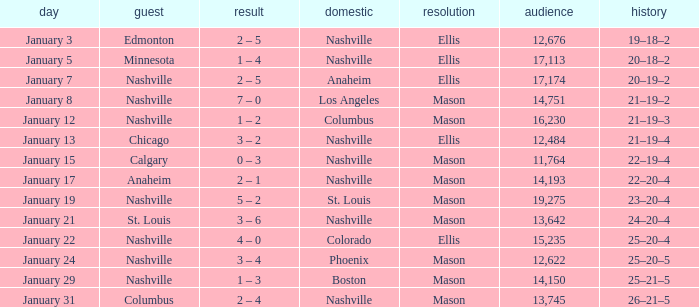On January 15, what was the most in attendance? 11764.0. 